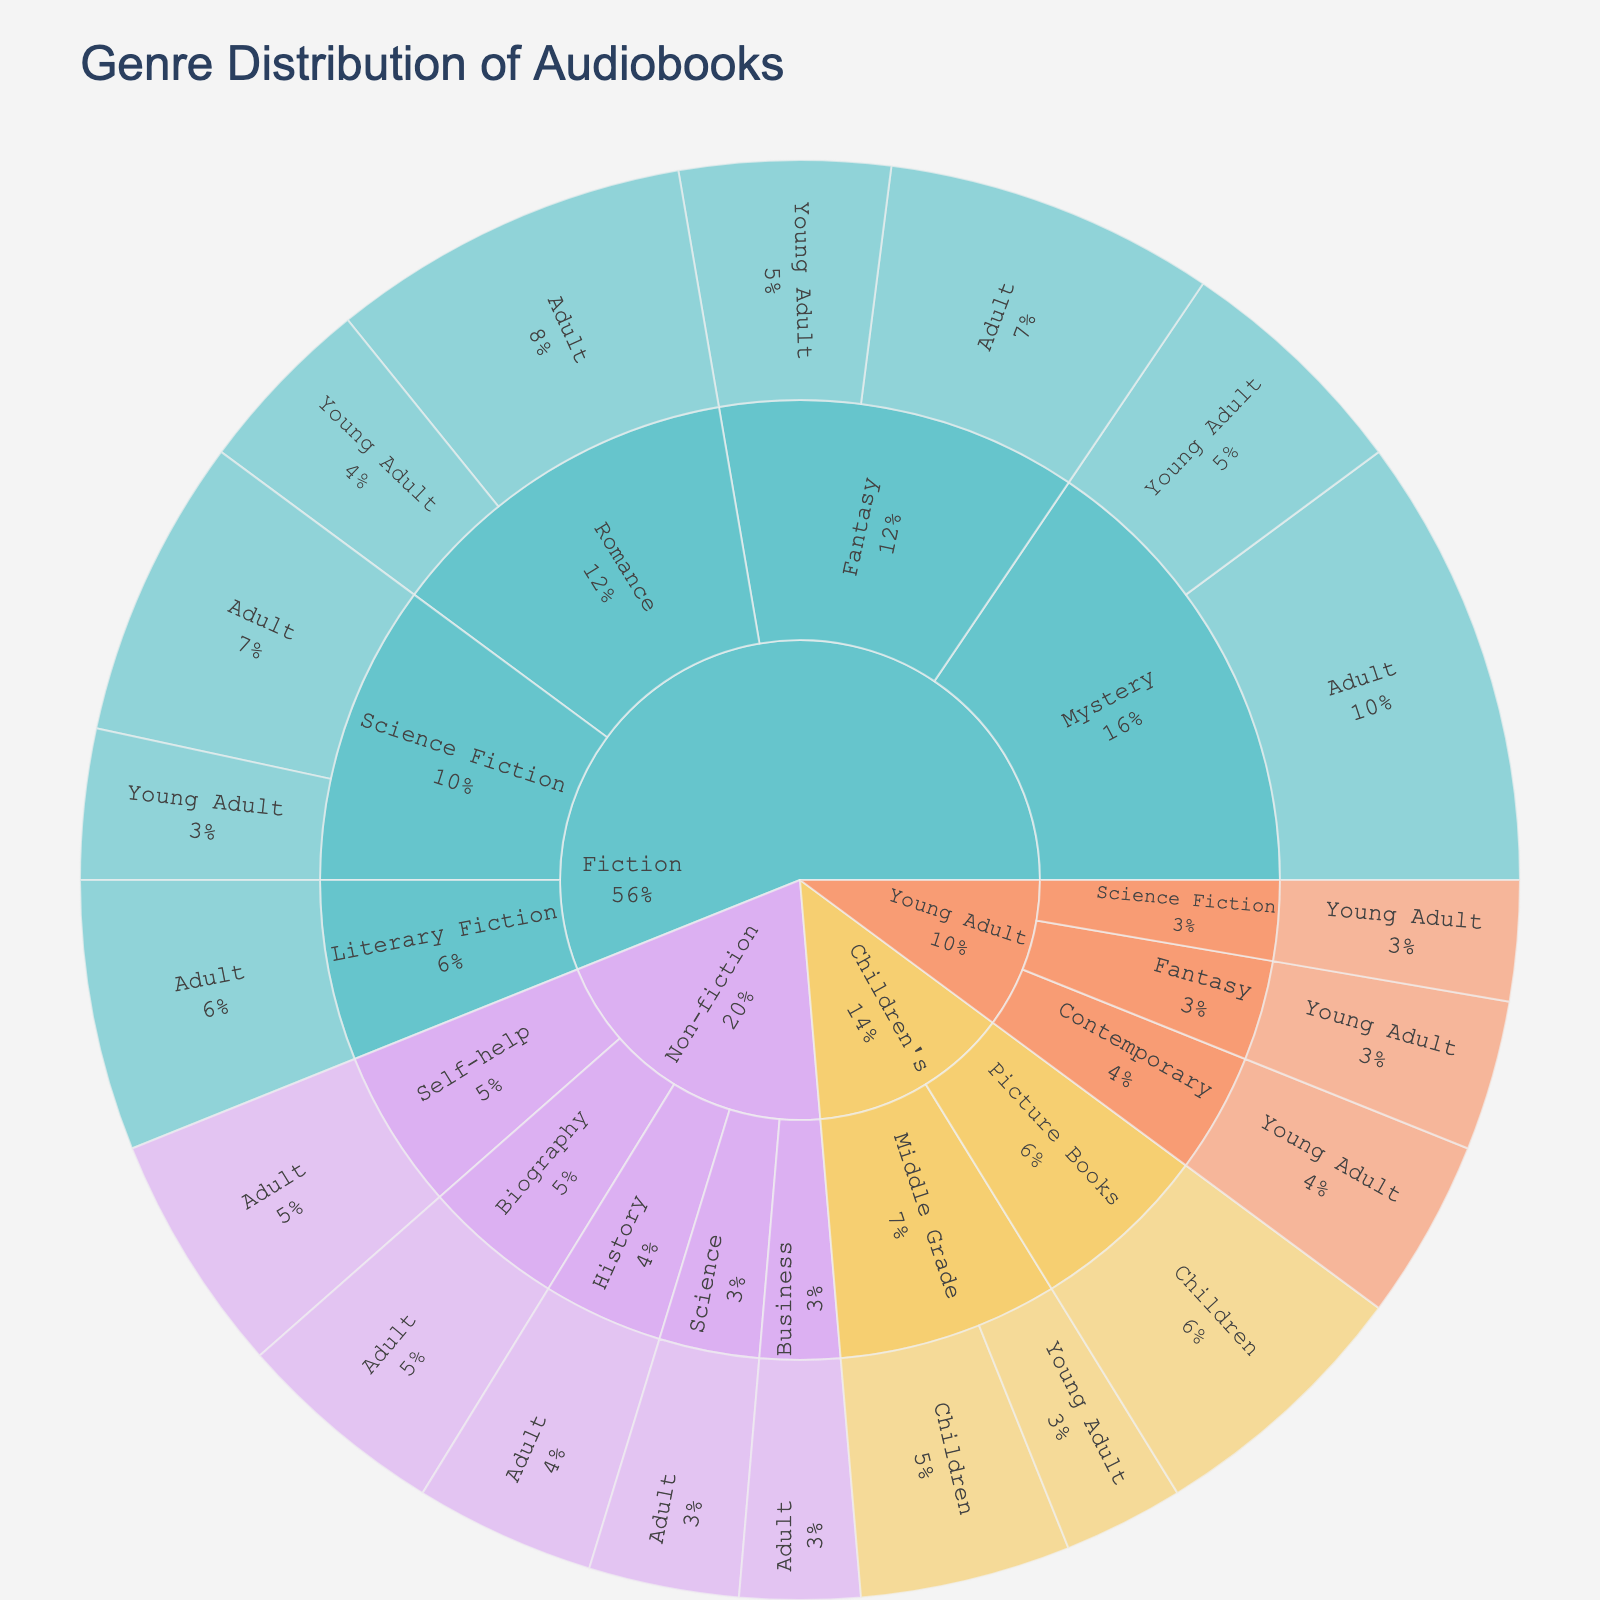What is the title of the figure? The title is usually displayed at the top of the plot, shown as "Genre Distribution of Audiobooks."
Answer: Genre Distribution of Audiobooks Which genre has the highest total value of audiobooks narrated? By observing the largest segment of the outermost layer, we identify the Fiction genre as having the highest total value.
Answer: Fiction How many sub-genres are there in total? Counting all unique sub-genre segments within all primary genres shows there are 15 unique sub-genres.
Answer: 15 Within the Fiction genre, which sub-genre has the highest value for the Adult age group? Under the Fiction genre, observe which sub-genre under the Adult age group has the largest share. Mystery has the highest value with 15.
Answer: Mystery Which age group has the lowest representation in the Romance sub-genre of Fiction? Examining the Romance sub-genre within Fiction, the Young Adult age group has a value of 6 compared to Adult's 12, making it the lowest.
Answer: Young Adult What is the combined value of Children's audiobooks? Adding the values of Picture Books (9) and Middle Grade groups (7 + 4), the total is 9 + 7 + 4 = 20.
Answer: 20 Compare the value of Science Fiction in the Fiction genre across Adult and Young Adult age groups. Which is higher? Science Fiction has values of 10 for Adult and 5 for Young Adult. Therefore, Adult is higher.
Answer: Adult What is the percentage representation of Young Adult audiobooks in the Mystery sub-genre of Fiction? The values for Mystery in Fiction are 15 (Adult) and 8 (Young Adult). The total is 15 + 8 = 23. The percentage is (8/23) * 100 ≈ 34.78%.
Answer: 34.78% How does the value representation of Fantasy in Fiction compare between Adult and Young Adult age groups? Fantasy's values for Adult are 11, and for Young Adult, it is 7. Adult is greater than Young Adult by a difference of 4.
Answer: Adult Which sub-genre has the highest total value under Non-fiction? Within Non-fiction, sum the values of each sub-genre. Self-help has the highest value of 8, when compared with Biography (7), History (6), Science (5), and Business (4).
Answer: Self-help 